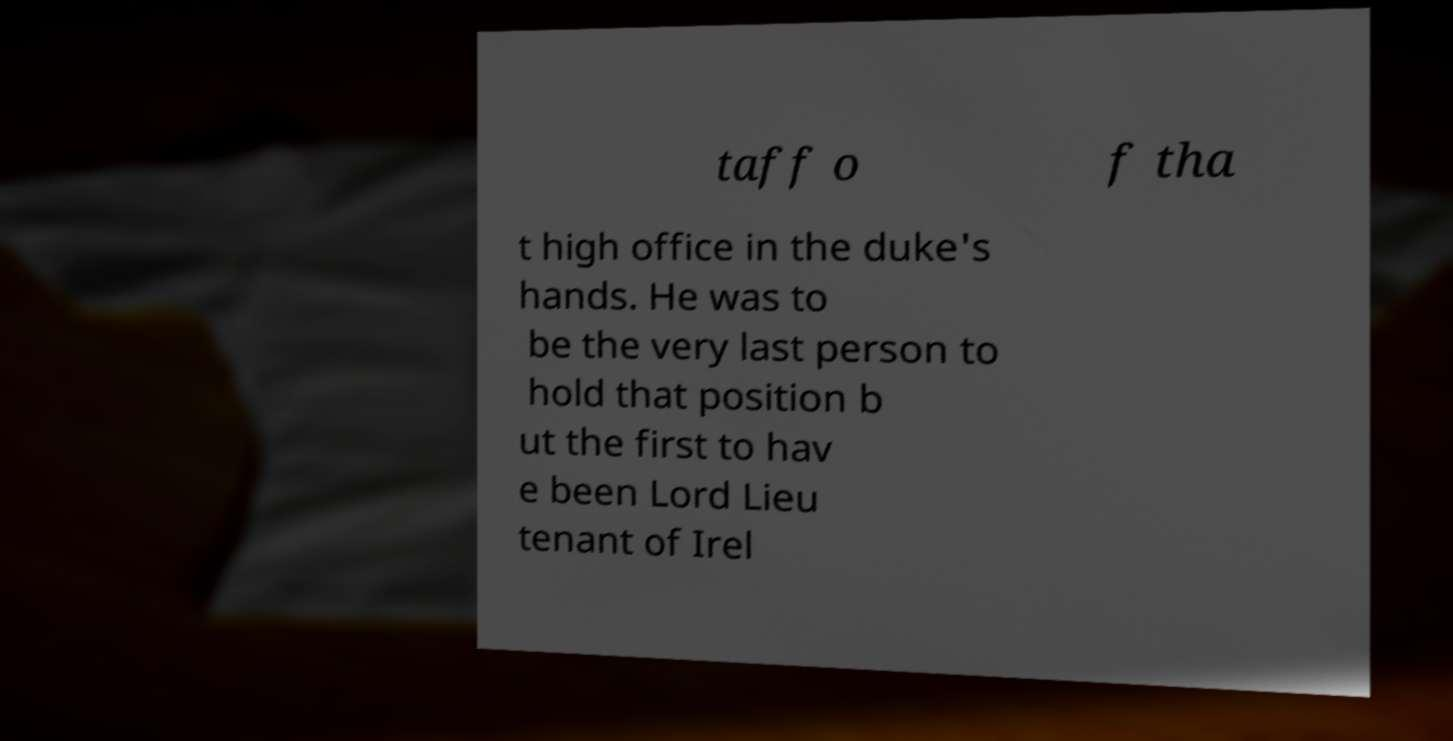Could you extract and type out the text from this image? taff o f tha t high office in the duke's hands. He was to be the very last person to hold that position b ut the first to hav e been Lord Lieu tenant of Irel 